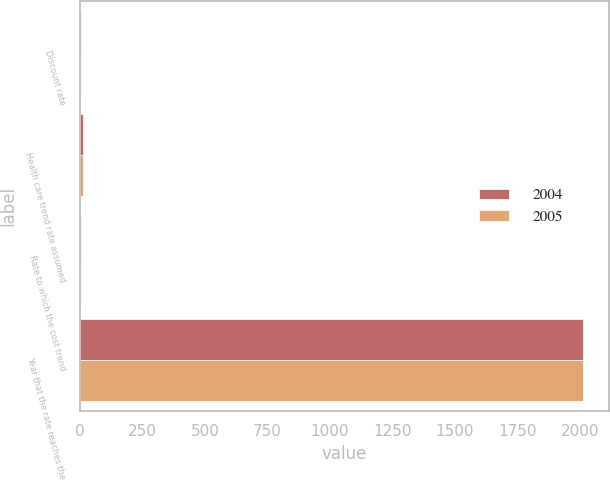Convert chart. <chart><loc_0><loc_0><loc_500><loc_500><stacked_bar_chart><ecel><fcel>Discount rate<fcel>Health care trend rate assumed<fcel>Rate to which the cost trend<fcel>Year that the rate reaches the<nl><fcel>2004<fcel>5.25<fcel>11<fcel>5<fcel>2014<nl><fcel>2005<fcel>6.25<fcel>12<fcel>5<fcel>2014<nl></chart> 